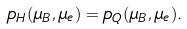Convert formula to latex. <formula><loc_0><loc_0><loc_500><loc_500>p _ { H } ( \mu _ { B } , \mu _ { e } ) = p _ { Q } ( \mu _ { B } , \mu _ { e } ) .</formula> 